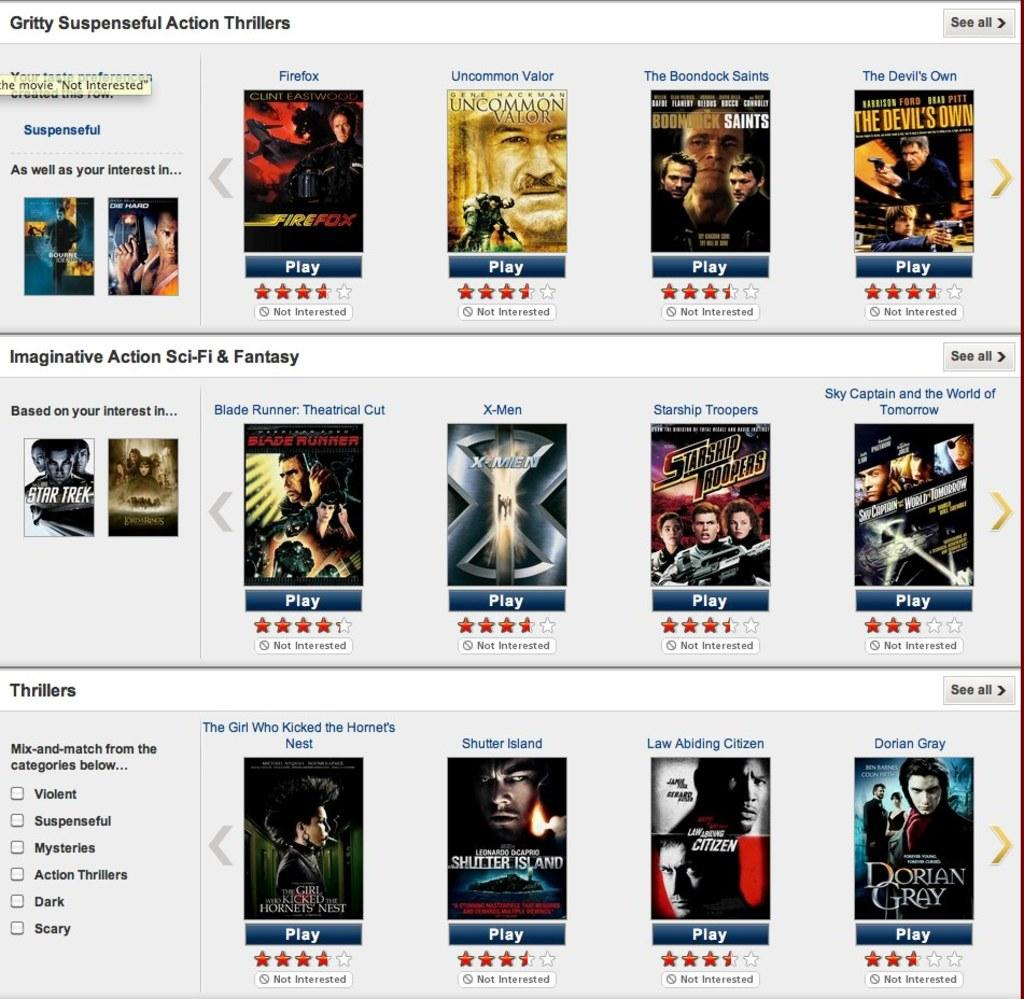<image>
Offer a succinct explanation of the picture presented. A screen displaying movie titles has Gritty Suspenseful Action Thrillers written at the top. 